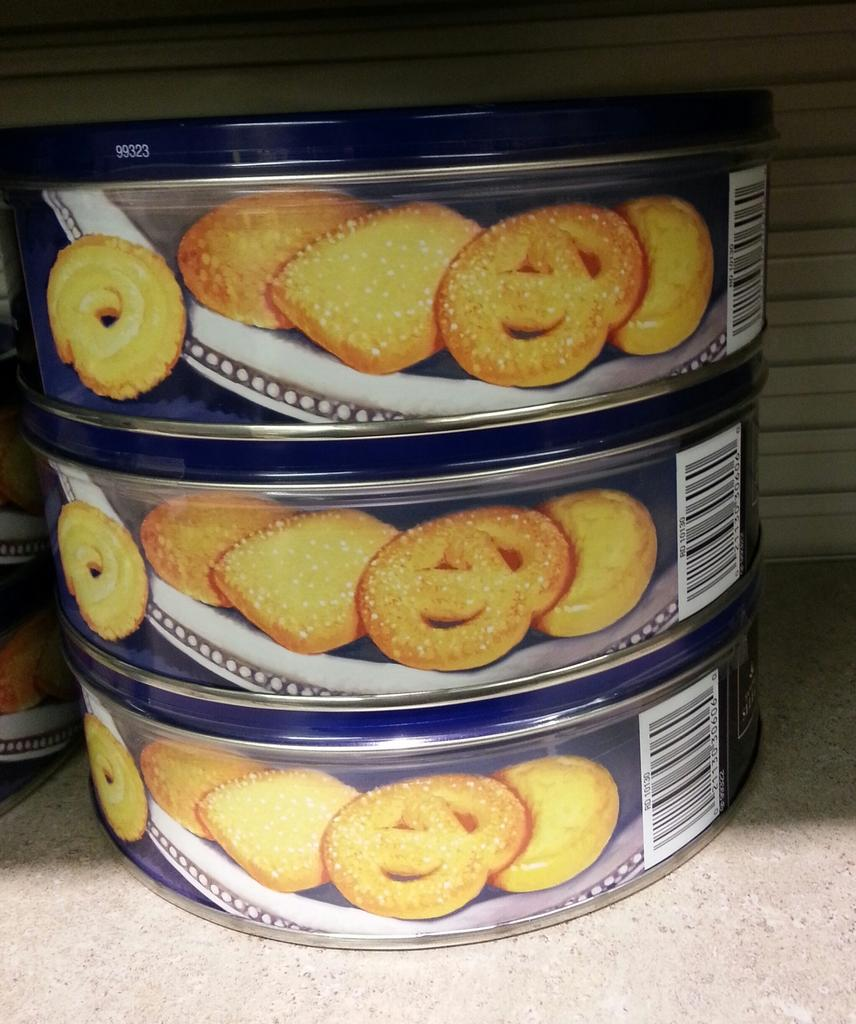How many cookie boxes are visible in the image? There are three cookie boxes in the image. How are the cookie boxes arranged? The cookie boxes are stacked one above the other. Where are the cookie boxes located? The cookie boxes are on a table. What can be seen in the background of the image? There is a wall visible in the background of the image. What type of haircut does the cookie box on the top have in the image? There is no haircut present in the image, as the subject is cookie boxes and not people or animals. 